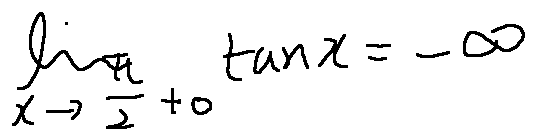Convert formula to latex. <formula><loc_0><loc_0><loc_500><loc_500>\lim \lim i t s _ { x \rightarrow \frac { \pi } { 2 } + 0 } \tan x = - \infty</formula> 